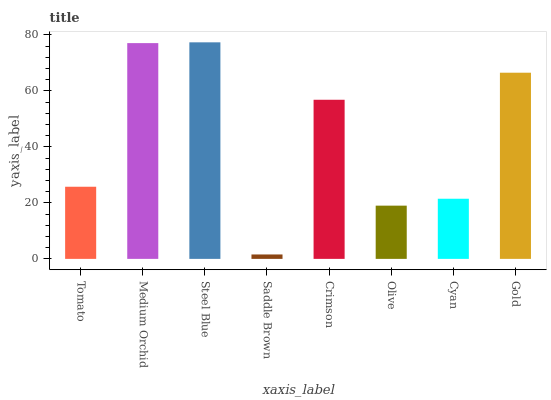Is Saddle Brown the minimum?
Answer yes or no. Yes. Is Steel Blue the maximum?
Answer yes or no. Yes. Is Medium Orchid the minimum?
Answer yes or no. No. Is Medium Orchid the maximum?
Answer yes or no. No. Is Medium Orchid greater than Tomato?
Answer yes or no. Yes. Is Tomato less than Medium Orchid?
Answer yes or no. Yes. Is Tomato greater than Medium Orchid?
Answer yes or no. No. Is Medium Orchid less than Tomato?
Answer yes or no. No. Is Crimson the high median?
Answer yes or no. Yes. Is Tomato the low median?
Answer yes or no. Yes. Is Tomato the high median?
Answer yes or no. No. Is Olive the low median?
Answer yes or no. No. 